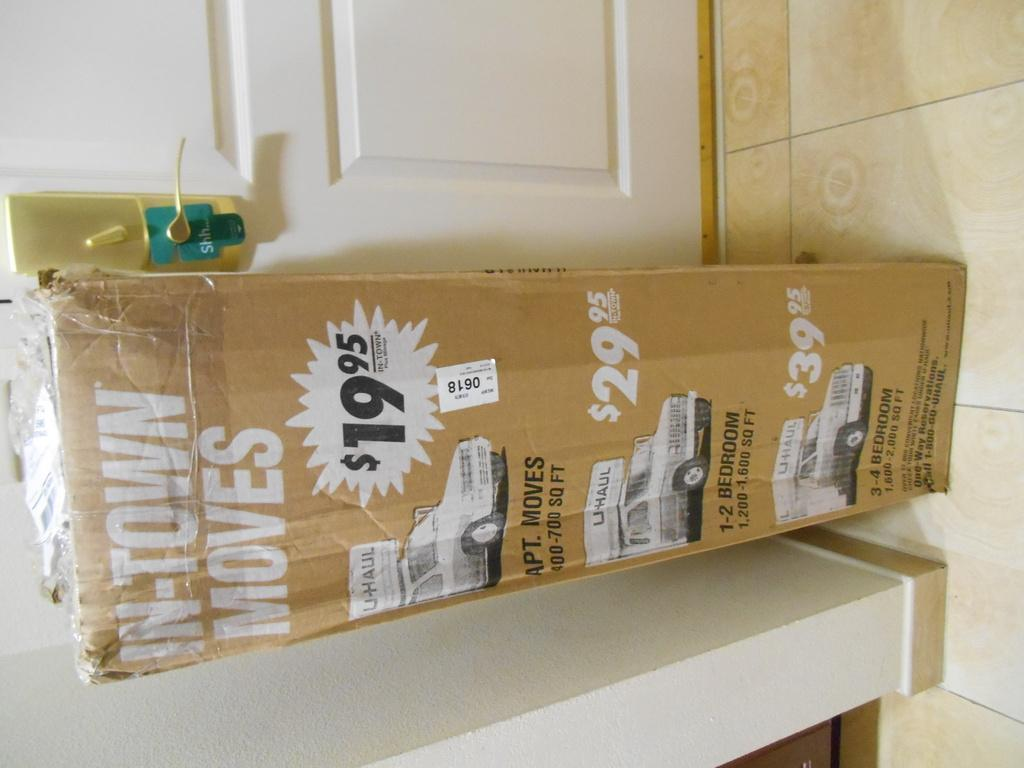<image>
Offer a succinct explanation of the picture presented. A cardboard box shows the prices of different U-haul trucks. 